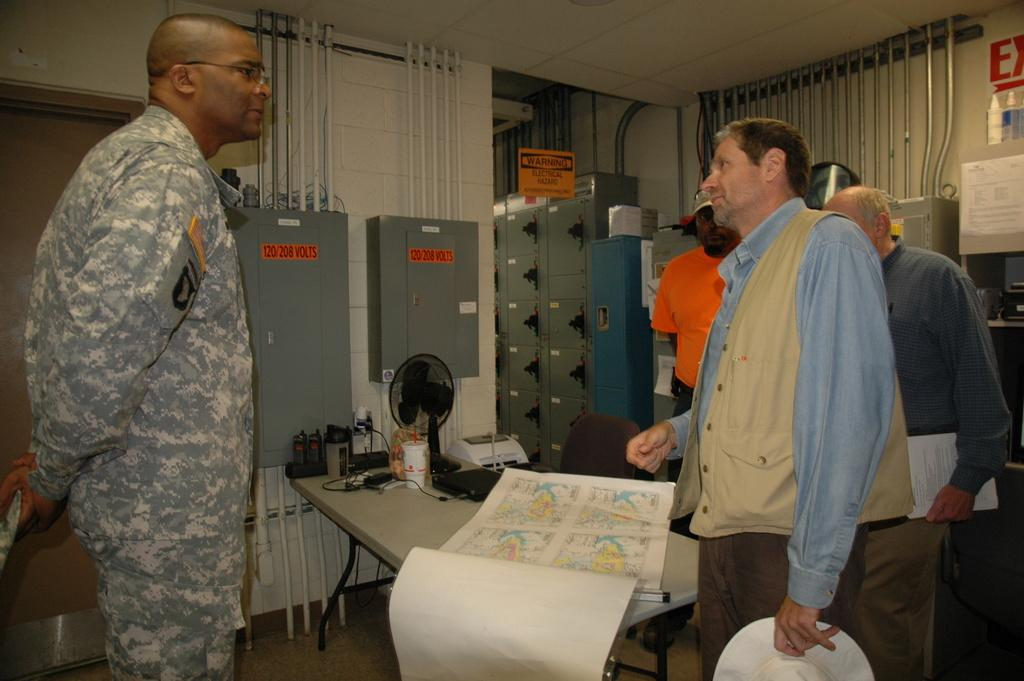How many people are in the image? There is a group of people in the image. What are the people in the image doing? The people are standing together and speaking to an officer. What object can be seen on the table in the image? A map is present on the table. What type of appliance is being used by the people in the image? There is no appliance visible in the image. What kind of suit is the officer wearing in the image? The image does not provide enough detail to determine the type of suit the officer might be wearing. 